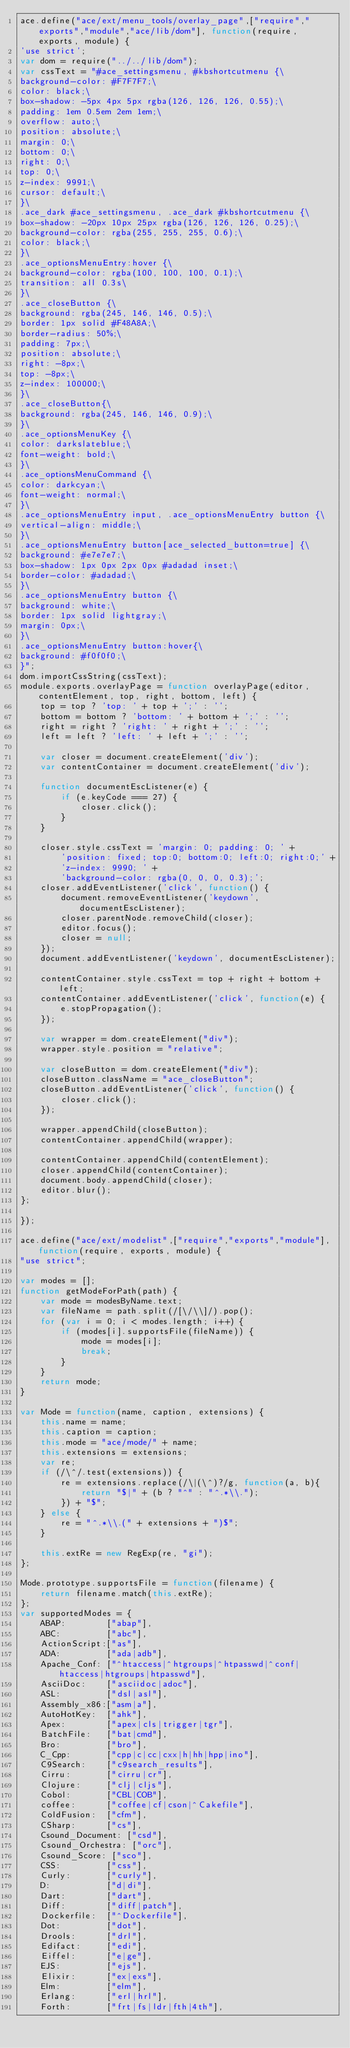Convert code to text. <code><loc_0><loc_0><loc_500><loc_500><_JavaScript_>ace.define("ace/ext/menu_tools/overlay_page",["require","exports","module","ace/lib/dom"], function(require, exports, module) {
'use strict';
var dom = require("../../lib/dom");
var cssText = "#ace_settingsmenu, #kbshortcutmenu {\
background-color: #F7F7F7;\
color: black;\
box-shadow: -5px 4px 5px rgba(126, 126, 126, 0.55);\
padding: 1em 0.5em 2em 1em;\
overflow: auto;\
position: absolute;\
margin: 0;\
bottom: 0;\
right: 0;\
top: 0;\
z-index: 9991;\
cursor: default;\
}\
.ace_dark #ace_settingsmenu, .ace_dark #kbshortcutmenu {\
box-shadow: -20px 10px 25px rgba(126, 126, 126, 0.25);\
background-color: rgba(255, 255, 255, 0.6);\
color: black;\
}\
.ace_optionsMenuEntry:hover {\
background-color: rgba(100, 100, 100, 0.1);\
transition: all 0.3s\
}\
.ace_closeButton {\
background: rgba(245, 146, 146, 0.5);\
border: 1px solid #F48A8A;\
border-radius: 50%;\
padding: 7px;\
position: absolute;\
right: -8px;\
top: -8px;\
z-index: 100000;\
}\
.ace_closeButton{\
background: rgba(245, 146, 146, 0.9);\
}\
.ace_optionsMenuKey {\
color: darkslateblue;\
font-weight: bold;\
}\
.ace_optionsMenuCommand {\
color: darkcyan;\
font-weight: normal;\
}\
.ace_optionsMenuEntry input, .ace_optionsMenuEntry button {\
vertical-align: middle;\
}\
.ace_optionsMenuEntry button[ace_selected_button=true] {\
background: #e7e7e7;\
box-shadow: 1px 0px 2px 0px #adadad inset;\
border-color: #adadad;\
}\
.ace_optionsMenuEntry button {\
background: white;\
border: 1px solid lightgray;\
margin: 0px;\
}\
.ace_optionsMenuEntry button:hover{\
background: #f0f0f0;\
}";
dom.importCssString(cssText);
module.exports.overlayPage = function overlayPage(editor, contentElement, top, right, bottom, left) {
    top = top ? 'top: ' + top + ';' : '';
    bottom = bottom ? 'bottom: ' + bottom + ';' : '';
    right = right ? 'right: ' + right + ';' : '';
    left = left ? 'left: ' + left + ';' : '';

    var closer = document.createElement('div');
    var contentContainer = document.createElement('div');

    function documentEscListener(e) {
        if (e.keyCode === 27) {
            closer.click();
        }
    }

    closer.style.cssText = 'margin: 0; padding: 0; ' +
        'position: fixed; top:0; bottom:0; left:0; right:0;' +
        'z-index: 9990; ' +
        'background-color: rgba(0, 0, 0, 0.3);';
    closer.addEventListener('click', function() {
        document.removeEventListener('keydown', documentEscListener);
        closer.parentNode.removeChild(closer);
        editor.focus();
        closer = null;
    });
    document.addEventListener('keydown', documentEscListener);

    contentContainer.style.cssText = top + right + bottom + left;
    contentContainer.addEventListener('click', function(e) {
        e.stopPropagation();
    });

    var wrapper = dom.createElement("div");
    wrapper.style.position = "relative";
    
    var closeButton = dom.createElement("div");
    closeButton.className = "ace_closeButton";
    closeButton.addEventListener('click', function() {
        closer.click();
    });
    
    wrapper.appendChild(closeButton);
    contentContainer.appendChild(wrapper);
    
    contentContainer.appendChild(contentElement);
    closer.appendChild(contentContainer);
    document.body.appendChild(closer);
    editor.blur();
};

});

ace.define("ace/ext/modelist",["require","exports","module"], function(require, exports, module) {
"use strict";

var modes = [];
function getModeForPath(path) {
    var mode = modesByName.text;
    var fileName = path.split(/[\/\\]/).pop();
    for (var i = 0; i < modes.length; i++) {
        if (modes[i].supportsFile(fileName)) {
            mode = modes[i];
            break;
        }
    }
    return mode;
}

var Mode = function(name, caption, extensions) {
    this.name = name;
    this.caption = caption;
    this.mode = "ace/mode/" + name;
    this.extensions = extensions;
    var re;
    if (/\^/.test(extensions)) {
        re = extensions.replace(/\|(\^)?/g, function(a, b){
            return "$|" + (b ? "^" : "^.*\\.");
        }) + "$";
    } else {
        re = "^.*\\.(" + extensions + ")$";
    }

    this.extRe = new RegExp(re, "gi");
};

Mode.prototype.supportsFile = function(filename) {
    return filename.match(this.extRe);
};
var supportedModes = {
    ABAP:        ["abap"],
    ABC:         ["abc"],
    ActionScript:["as"],
    ADA:         ["ada|adb"],
    Apache_Conf: ["^htaccess|^htgroups|^htpasswd|^conf|htaccess|htgroups|htpasswd"],
    AsciiDoc:    ["asciidoc|adoc"],
    ASL:         ["dsl|asl"],
    Assembly_x86:["asm|a"],
    AutoHotKey:  ["ahk"],
    Apex:        ["apex|cls|trigger|tgr"],
    BatchFile:   ["bat|cmd"],
    Bro:         ["bro"],
    C_Cpp:       ["cpp|c|cc|cxx|h|hh|hpp|ino"],
    C9Search:    ["c9search_results"],
    Cirru:       ["cirru|cr"],
    Clojure:     ["clj|cljs"],
    Cobol:       ["CBL|COB"],
    coffee:      ["coffee|cf|cson|^Cakefile"],
    ColdFusion:  ["cfm"],
    CSharp:      ["cs"],
    Csound_Document: ["csd"],
    Csound_Orchestra: ["orc"],
    Csound_Score: ["sco"],
    CSS:         ["css"],
    Curly:       ["curly"],
    D:           ["d|di"],
    Dart:        ["dart"],
    Diff:        ["diff|patch"],
    Dockerfile:  ["^Dockerfile"],
    Dot:         ["dot"],
    Drools:      ["drl"],
    Edifact:     ["edi"],
    Eiffel:      ["e|ge"],
    EJS:         ["ejs"],
    Elixir:      ["ex|exs"],
    Elm:         ["elm"],
    Erlang:      ["erl|hrl"],
    Forth:       ["frt|fs|ldr|fth|4th"],</code> 